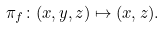<formula> <loc_0><loc_0><loc_500><loc_500>\pi _ { f } \colon ( x , y , z ) \mapsto ( x , z ) .</formula> 